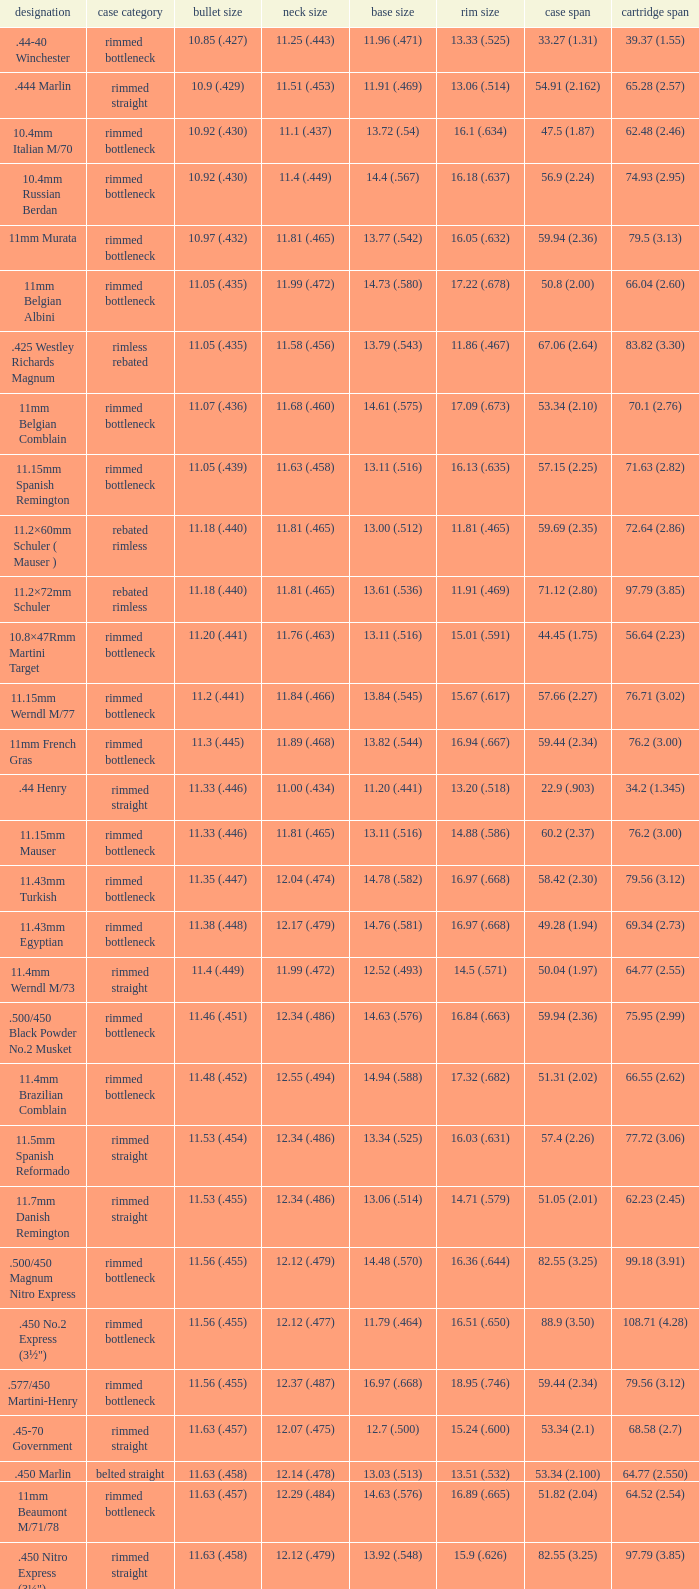Which Case type has a Base diameter of 13.03 (.513), and a Case length of 63.5 (2.5)? Belted straight. 